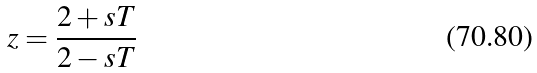Convert formula to latex. <formula><loc_0><loc_0><loc_500><loc_500>z = \frac { 2 + s T } { 2 - s T }</formula> 